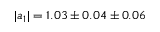<formula> <loc_0><loc_0><loc_500><loc_500>| a _ { 1 } | = 1 . 0 3 \pm 0 . 0 4 \pm 0 . 0 6</formula> 